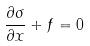<formula> <loc_0><loc_0><loc_500><loc_500>\frac { \partial \sigma } { \partial x } + f = 0</formula> 